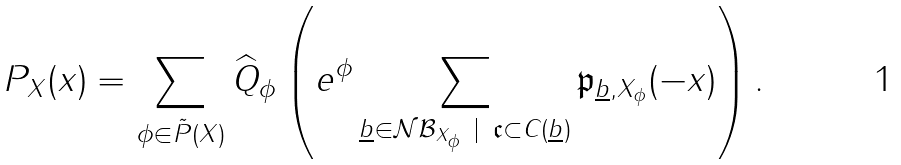Convert formula to latex. <formula><loc_0><loc_0><loc_500><loc_500>P _ { X } ( x ) = \sum _ { \phi \in \tilde { P } ( X ) } \widehat { Q } _ { \phi } \left ( e ^ { \phi } \sum _ { \underline { b } \in \mathcal { N B } _ { X _ { \phi } } \ | \ \mathfrak c \subset C ( \underline { b } ) } \mathfrak p _ { \underline { b } , X _ { \phi } } ( - x ) \right ) .</formula> 